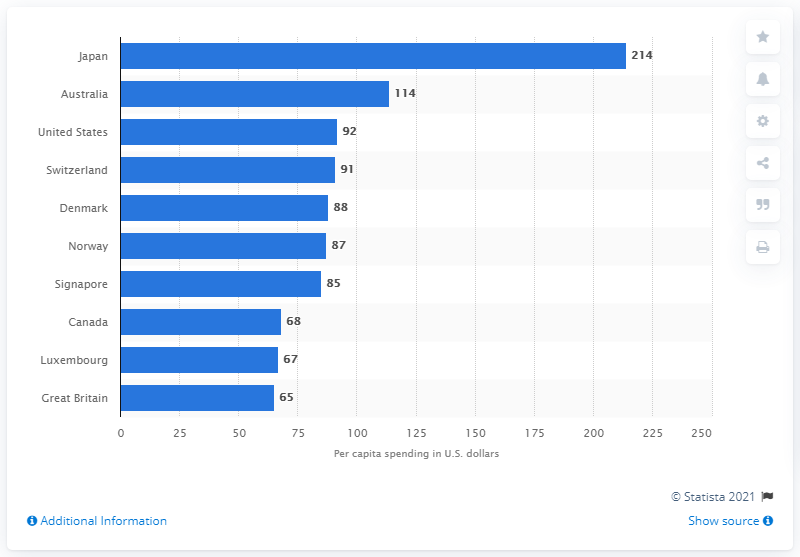Point out several critical features in this image. During the period from 2012 to 2017, Japan's average spending on iOS apps per person was 214 U.S. dollars. During the measured period, Australia spent 114 U.S. dollars on iOS apps. 